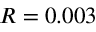Convert formula to latex. <formula><loc_0><loc_0><loc_500><loc_500>R = 0 . 0 0 3 \</formula> 